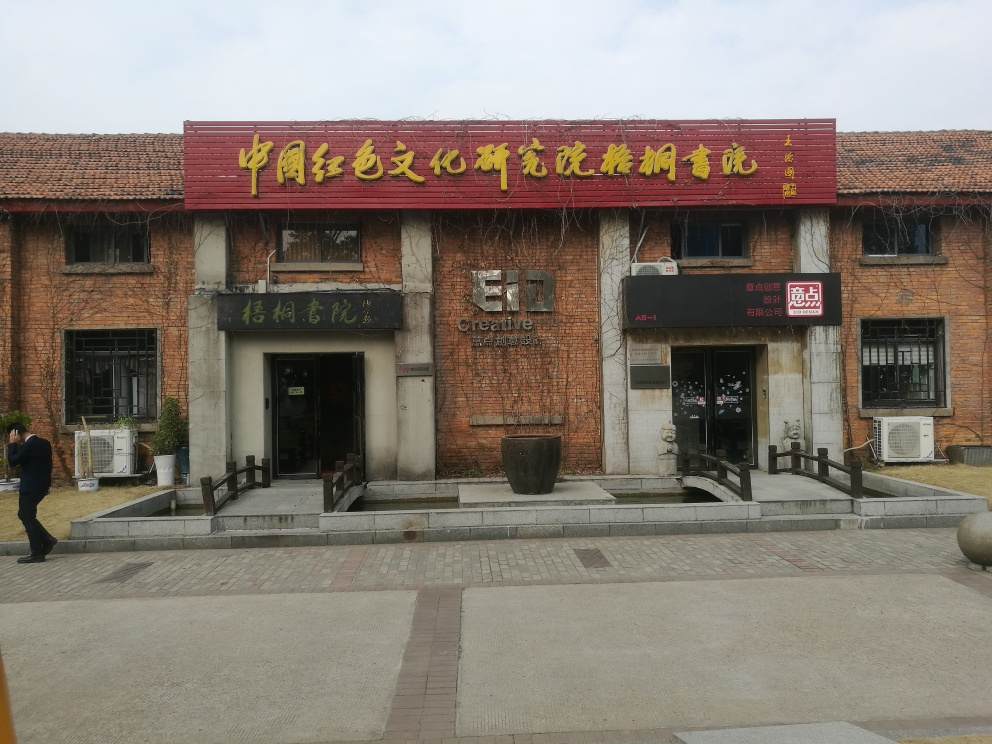Is there any distortion in the image? The image appears to be clear without any noticeable distortion. It evident by the brickwork, window frames, and signage which all have straight lines that seem true to their real-world counterparts. 